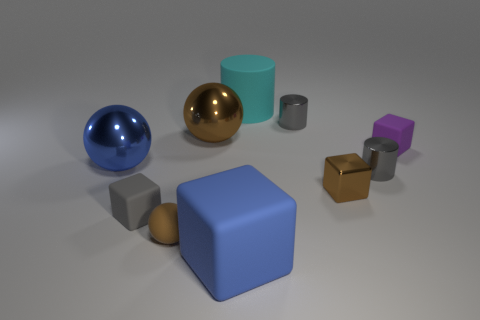How big is the metal ball behind the blue shiny sphere?
Your answer should be very brief. Large. There is a big shiny object that is in front of the large brown sphere; does it have the same color as the tiny metallic cylinder that is behind the tiny purple matte thing?
Your answer should be very brief. No. What number of other things are there of the same shape as the cyan thing?
Provide a succinct answer. 2. Are there the same number of balls that are on the left side of the brown matte sphere and metal cylinders that are behind the large brown ball?
Give a very brief answer. Yes. Is the material of the brown sphere behind the purple cube the same as the tiny cylinder that is to the right of the brown shiny block?
Your answer should be compact. Yes. What number of other objects are there of the same size as the brown block?
Ensure brevity in your answer.  5. What number of objects are brown balls or objects left of the blue rubber thing?
Provide a short and direct response. 4. Are there the same number of cyan matte things behind the big cylinder and blue metallic objects?
Your answer should be compact. No. What is the shape of the blue object that is made of the same material as the tiny purple block?
Your response must be concise. Cube. Is there another big cylinder of the same color as the large cylinder?
Your response must be concise. No. 